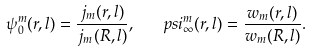<formula> <loc_0><loc_0><loc_500><loc_500>\psi ^ { m } _ { 0 } ( r , l ) = \frac { j _ { m } ( r , l ) } { j _ { m } ( R , l ) } , \ \ \ p s i ^ { m } _ { \infty } ( r , l ) = \frac { w _ { m } ( r , l ) } { w _ { m } ( R , l ) } .</formula> 